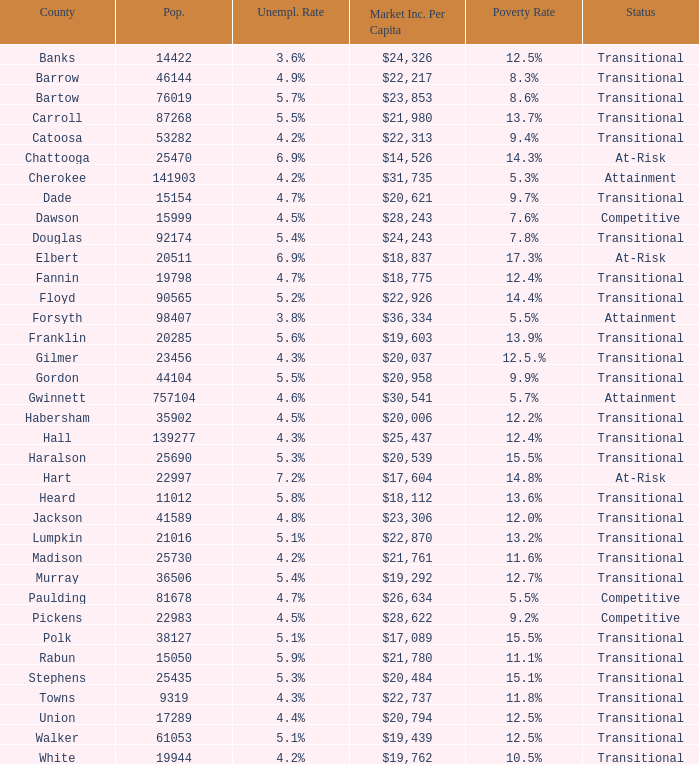Which county had a 3.6% unemployment rate? Banks. 